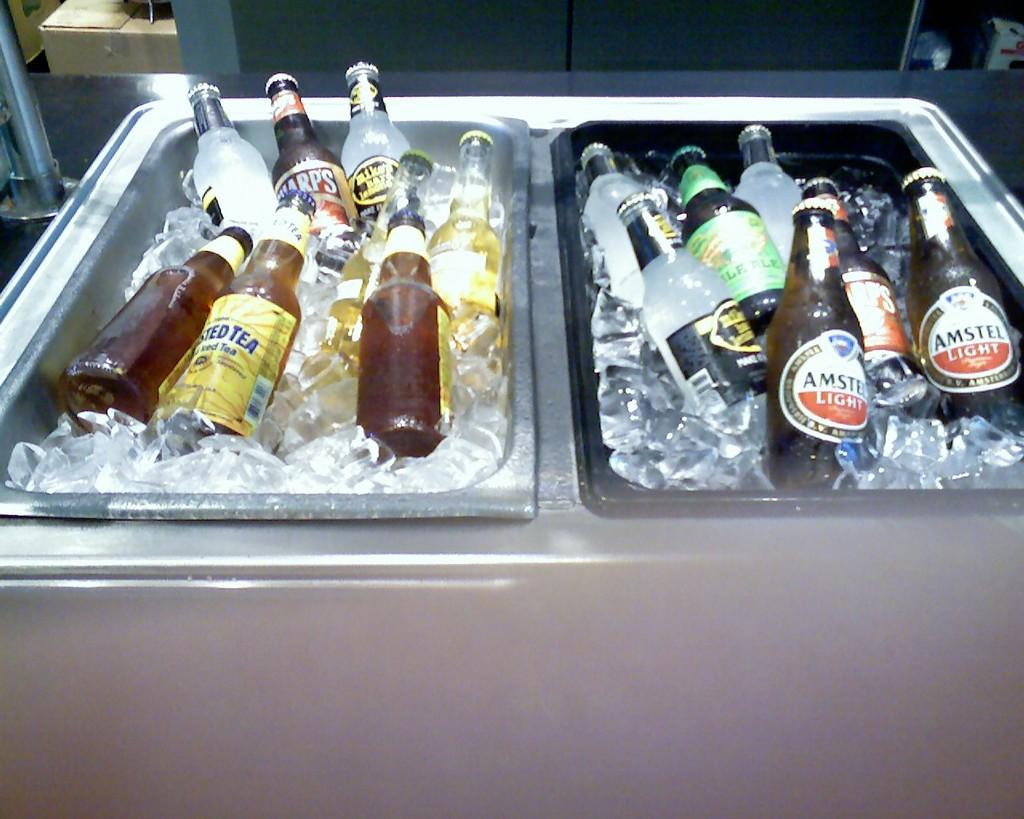<image>
Relay a brief, clear account of the picture shown. Bottles of Amstel Light are on ice in the right container. 